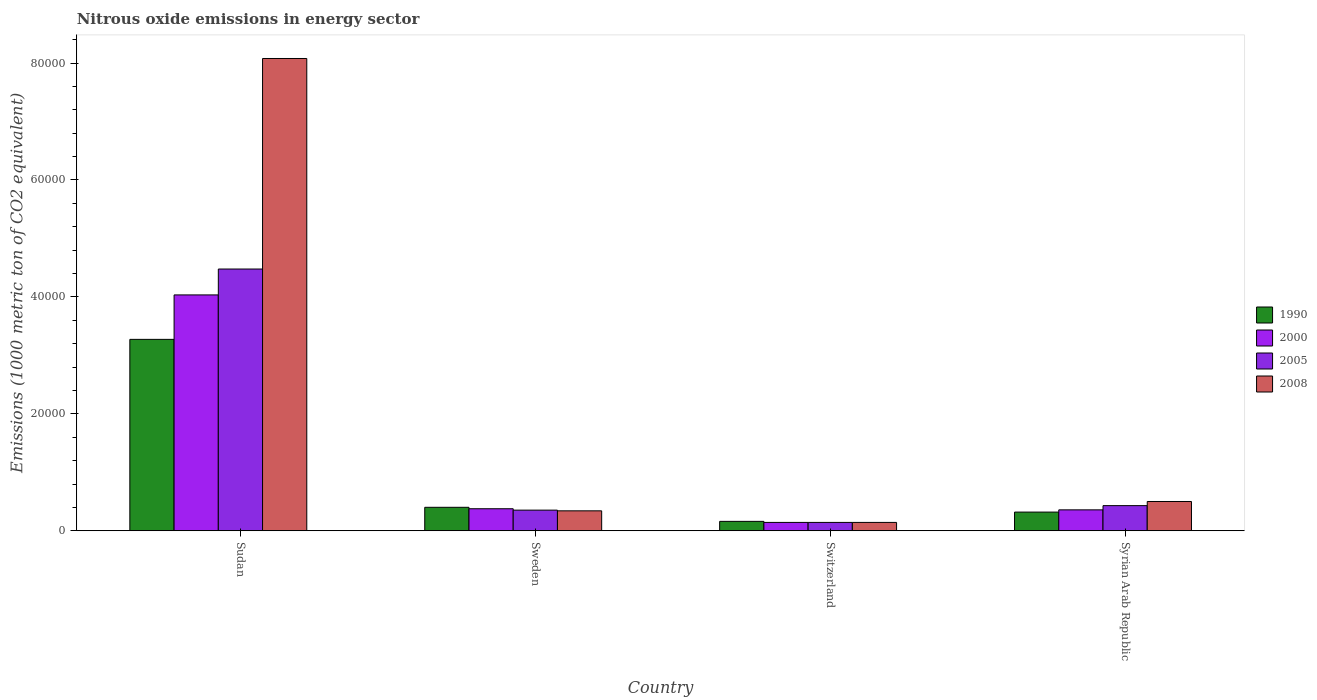How many different coloured bars are there?
Provide a succinct answer. 4. How many groups of bars are there?
Keep it short and to the point. 4. Are the number of bars per tick equal to the number of legend labels?
Provide a short and direct response. Yes. Are the number of bars on each tick of the X-axis equal?
Your answer should be compact. Yes. How many bars are there on the 2nd tick from the right?
Ensure brevity in your answer.  4. What is the label of the 1st group of bars from the left?
Ensure brevity in your answer.  Sudan. In how many cases, is the number of bars for a given country not equal to the number of legend labels?
Your response must be concise. 0. What is the amount of nitrous oxide emitted in 2005 in Syrian Arab Republic?
Make the answer very short. 4302.7. Across all countries, what is the maximum amount of nitrous oxide emitted in 2005?
Offer a very short reply. 4.48e+04. Across all countries, what is the minimum amount of nitrous oxide emitted in 1990?
Ensure brevity in your answer.  1610.2. In which country was the amount of nitrous oxide emitted in 2008 maximum?
Ensure brevity in your answer.  Sudan. In which country was the amount of nitrous oxide emitted in 2005 minimum?
Ensure brevity in your answer.  Switzerland. What is the total amount of nitrous oxide emitted in 2008 in the graph?
Offer a terse response. 9.06e+04. What is the difference between the amount of nitrous oxide emitted in 2005 in Sweden and that in Syrian Arab Republic?
Your answer should be compact. -769.3. What is the difference between the amount of nitrous oxide emitted in 2005 in Sudan and the amount of nitrous oxide emitted in 2008 in Sweden?
Your answer should be compact. 4.14e+04. What is the average amount of nitrous oxide emitted in 2008 per country?
Ensure brevity in your answer.  2.27e+04. What is the difference between the amount of nitrous oxide emitted of/in 2000 and amount of nitrous oxide emitted of/in 2008 in Sudan?
Provide a short and direct response. -4.04e+04. What is the ratio of the amount of nitrous oxide emitted in 1990 in Sudan to that in Sweden?
Make the answer very short. 8.15. Is the amount of nitrous oxide emitted in 1990 in Sudan less than that in Syrian Arab Republic?
Keep it short and to the point. No. What is the difference between the highest and the second highest amount of nitrous oxide emitted in 2005?
Your answer should be compact. -769.3. What is the difference between the highest and the lowest amount of nitrous oxide emitted in 2008?
Your answer should be compact. 7.93e+04. What does the 2nd bar from the left in Syrian Arab Republic represents?
Your response must be concise. 2000. Is it the case that in every country, the sum of the amount of nitrous oxide emitted in 1990 and amount of nitrous oxide emitted in 2000 is greater than the amount of nitrous oxide emitted in 2008?
Offer a very short reply. No. Are all the bars in the graph horizontal?
Your response must be concise. No. What is the difference between two consecutive major ticks on the Y-axis?
Offer a very short reply. 2.00e+04. Does the graph contain grids?
Keep it short and to the point. No. What is the title of the graph?
Provide a succinct answer. Nitrous oxide emissions in energy sector. What is the label or title of the Y-axis?
Ensure brevity in your answer.  Emissions (1000 metric ton of CO2 equivalent). What is the Emissions (1000 metric ton of CO2 equivalent) in 1990 in Sudan?
Provide a short and direct response. 3.27e+04. What is the Emissions (1000 metric ton of CO2 equivalent) in 2000 in Sudan?
Offer a very short reply. 4.03e+04. What is the Emissions (1000 metric ton of CO2 equivalent) of 2005 in Sudan?
Provide a succinct answer. 4.48e+04. What is the Emissions (1000 metric ton of CO2 equivalent) in 2008 in Sudan?
Offer a very short reply. 8.08e+04. What is the Emissions (1000 metric ton of CO2 equivalent) of 1990 in Sweden?
Ensure brevity in your answer.  4016.7. What is the Emissions (1000 metric ton of CO2 equivalent) in 2000 in Sweden?
Make the answer very short. 3769. What is the Emissions (1000 metric ton of CO2 equivalent) in 2005 in Sweden?
Offer a terse response. 3533.4. What is the Emissions (1000 metric ton of CO2 equivalent) in 2008 in Sweden?
Ensure brevity in your answer.  3412.4. What is the Emissions (1000 metric ton of CO2 equivalent) in 1990 in Switzerland?
Your answer should be compact. 1610.2. What is the Emissions (1000 metric ton of CO2 equivalent) in 2000 in Switzerland?
Your response must be concise. 1432.5. What is the Emissions (1000 metric ton of CO2 equivalent) in 2005 in Switzerland?
Offer a terse response. 1431.1. What is the Emissions (1000 metric ton of CO2 equivalent) in 2008 in Switzerland?
Make the answer very short. 1433. What is the Emissions (1000 metric ton of CO2 equivalent) of 1990 in Syrian Arab Republic?
Make the answer very short. 3198.5. What is the Emissions (1000 metric ton of CO2 equivalent) in 2000 in Syrian Arab Republic?
Ensure brevity in your answer.  3579.1. What is the Emissions (1000 metric ton of CO2 equivalent) in 2005 in Syrian Arab Republic?
Offer a very short reply. 4302.7. What is the Emissions (1000 metric ton of CO2 equivalent) of 2008 in Syrian Arab Republic?
Ensure brevity in your answer.  5009.9. Across all countries, what is the maximum Emissions (1000 metric ton of CO2 equivalent) in 1990?
Provide a succinct answer. 3.27e+04. Across all countries, what is the maximum Emissions (1000 metric ton of CO2 equivalent) in 2000?
Your response must be concise. 4.03e+04. Across all countries, what is the maximum Emissions (1000 metric ton of CO2 equivalent) in 2005?
Provide a succinct answer. 4.48e+04. Across all countries, what is the maximum Emissions (1000 metric ton of CO2 equivalent) of 2008?
Provide a short and direct response. 8.08e+04. Across all countries, what is the minimum Emissions (1000 metric ton of CO2 equivalent) in 1990?
Provide a succinct answer. 1610.2. Across all countries, what is the minimum Emissions (1000 metric ton of CO2 equivalent) in 2000?
Give a very brief answer. 1432.5. Across all countries, what is the minimum Emissions (1000 metric ton of CO2 equivalent) of 2005?
Make the answer very short. 1431.1. Across all countries, what is the minimum Emissions (1000 metric ton of CO2 equivalent) of 2008?
Provide a short and direct response. 1433. What is the total Emissions (1000 metric ton of CO2 equivalent) in 1990 in the graph?
Offer a terse response. 4.16e+04. What is the total Emissions (1000 metric ton of CO2 equivalent) in 2000 in the graph?
Your answer should be compact. 4.91e+04. What is the total Emissions (1000 metric ton of CO2 equivalent) of 2005 in the graph?
Keep it short and to the point. 5.40e+04. What is the total Emissions (1000 metric ton of CO2 equivalent) in 2008 in the graph?
Offer a terse response. 9.06e+04. What is the difference between the Emissions (1000 metric ton of CO2 equivalent) of 1990 in Sudan and that in Sweden?
Give a very brief answer. 2.87e+04. What is the difference between the Emissions (1000 metric ton of CO2 equivalent) in 2000 in Sudan and that in Sweden?
Provide a succinct answer. 3.66e+04. What is the difference between the Emissions (1000 metric ton of CO2 equivalent) in 2005 in Sudan and that in Sweden?
Provide a succinct answer. 4.12e+04. What is the difference between the Emissions (1000 metric ton of CO2 equivalent) in 2008 in Sudan and that in Sweden?
Your answer should be compact. 7.74e+04. What is the difference between the Emissions (1000 metric ton of CO2 equivalent) of 1990 in Sudan and that in Switzerland?
Make the answer very short. 3.11e+04. What is the difference between the Emissions (1000 metric ton of CO2 equivalent) in 2000 in Sudan and that in Switzerland?
Your answer should be compact. 3.89e+04. What is the difference between the Emissions (1000 metric ton of CO2 equivalent) of 2005 in Sudan and that in Switzerland?
Offer a very short reply. 4.33e+04. What is the difference between the Emissions (1000 metric ton of CO2 equivalent) in 2008 in Sudan and that in Switzerland?
Your answer should be compact. 7.93e+04. What is the difference between the Emissions (1000 metric ton of CO2 equivalent) of 1990 in Sudan and that in Syrian Arab Republic?
Give a very brief answer. 2.95e+04. What is the difference between the Emissions (1000 metric ton of CO2 equivalent) in 2000 in Sudan and that in Syrian Arab Republic?
Your answer should be very brief. 3.68e+04. What is the difference between the Emissions (1000 metric ton of CO2 equivalent) of 2005 in Sudan and that in Syrian Arab Republic?
Keep it short and to the point. 4.05e+04. What is the difference between the Emissions (1000 metric ton of CO2 equivalent) in 2008 in Sudan and that in Syrian Arab Republic?
Offer a terse response. 7.58e+04. What is the difference between the Emissions (1000 metric ton of CO2 equivalent) in 1990 in Sweden and that in Switzerland?
Keep it short and to the point. 2406.5. What is the difference between the Emissions (1000 metric ton of CO2 equivalent) of 2000 in Sweden and that in Switzerland?
Your answer should be very brief. 2336.5. What is the difference between the Emissions (1000 metric ton of CO2 equivalent) in 2005 in Sweden and that in Switzerland?
Your answer should be compact. 2102.3. What is the difference between the Emissions (1000 metric ton of CO2 equivalent) in 2008 in Sweden and that in Switzerland?
Offer a terse response. 1979.4. What is the difference between the Emissions (1000 metric ton of CO2 equivalent) in 1990 in Sweden and that in Syrian Arab Republic?
Provide a succinct answer. 818.2. What is the difference between the Emissions (1000 metric ton of CO2 equivalent) of 2000 in Sweden and that in Syrian Arab Republic?
Make the answer very short. 189.9. What is the difference between the Emissions (1000 metric ton of CO2 equivalent) in 2005 in Sweden and that in Syrian Arab Republic?
Offer a terse response. -769.3. What is the difference between the Emissions (1000 metric ton of CO2 equivalent) of 2008 in Sweden and that in Syrian Arab Republic?
Keep it short and to the point. -1597.5. What is the difference between the Emissions (1000 metric ton of CO2 equivalent) in 1990 in Switzerland and that in Syrian Arab Republic?
Provide a short and direct response. -1588.3. What is the difference between the Emissions (1000 metric ton of CO2 equivalent) in 2000 in Switzerland and that in Syrian Arab Republic?
Keep it short and to the point. -2146.6. What is the difference between the Emissions (1000 metric ton of CO2 equivalent) of 2005 in Switzerland and that in Syrian Arab Republic?
Your answer should be compact. -2871.6. What is the difference between the Emissions (1000 metric ton of CO2 equivalent) in 2008 in Switzerland and that in Syrian Arab Republic?
Provide a short and direct response. -3576.9. What is the difference between the Emissions (1000 metric ton of CO2 equivalent) of 1990 in Sudan and the Emissions (1000 metric ton of CO2 equivalent) of 2000 in Sweden?
Provide a short and direct response. 2.90e+04. What is the difference between the Emissions (1000 metric ton of CO2 equivalent) of 1990 in Sudan and the Emissions (1000 metric ton of CO2 equivalent) of 2005 in Sweden?
Provide a succinct answer. 2.92e+04. What is the difference between the Emissions (1000 metric ton of CO2 equivalent) of 1990 in Sudan and the Emissions (1000 metric ton of CO2 equivalent) of 2008 in Sweden?
Offer a terse response. 2.93e+04. What is the difference between the Emissions (1000 metric ton of CO2 equivalent) in 2000 in Sudan and the Emissions (1000 metric ton of CO2 equivalent) in 2005 in Sweden?
Give a very brief answer. 3.68e+04. What is the difference between the Emissions (1000 metric ton of CO2 equivalent) of 2000 in Sudan and the Emissions (1000 metric ton of CO2 equivalent) of 2008 in Sweden?
Keep it short and to the point. 3.69e+04. What is the difference between the Emissions (1000 metric ton of CO2 equivalent) of 2005 in Sudan and the Emissions (1000 metric ton of CO2 equivalent) of 2008 in Sweden?
Keep it short and to the point. 4.14e+04. What is the difference between the Emissions (1000 metric ton of CO2 equivalent) in 1990 in Sudan and the Emissions (1000 metric ton of CO2 equivalent) in 2000 in Switzerland?
Your answer should be compact. 3.13e+04. What is the difference between the Emissions (1000 metric ton of CO2 equivalent) of 1990 in Sudan and the Emissions (1000 metric ton of CO2 equivalent) of 2005 in Switzerland?
Your response must be concise. 3.13e+04. What is the difference between the Emissions (1000 metric ton of CO2 equivalent) of 1990 in Sudan and the Emissions (1000 metric ton of CO2 equivalent) of 2008 in Switzerland?
Your answer should be compact. 3.13e+04. What is the difference between the Emissions (1000 metric ton of CO2 equivalent) of 2000 in Sudan and the Emissions (1000 metric ton of CO2 equivalent) of 2005 in Switzerland?
Your answer should be very brief. 3.89e+04. What is the difference between the Emissions (1000 metric ton of CO2 equivalent) in 2000 in Sudan and the Emissions (1000 metric ton of CO2 equivalent) in 2008 in Switzerland?
Keep it short and to the point. 3.89e+04. What is the difference between the Emissions (1000 metric ton of CO2 equivalent) in 2005 in Sudan and the Emissions (1000 metric ton of CO2 equivalent) in 2008 in Switzerland?
Provide a short and direct response. 4.33e+04. What is the difference between the Emissions (1000 metric ton of CO2 equivalent) of 1990 in Sudan and the Emissions (1000 metric ton of CO2 equivalent) of 2000 in Syrian Arab Republic?
Your response must be concise. 2.92e+04. What is the difference between the Emissions (1000 metric ton of CO2 equivalent) of 1990 in Sudan and the Emissions (1000 metric ton of CO2 equivalent) of 2005 in Syrian Arab Republic?
Give a very brief answer. 2.84e+04. What is the difference between the Emissions (1000 metric ton of CO2 equivalent) in 1990 in Sudan and the Emissions (1000 metric ton of CO2 equivalent) in 2008 in Syrian Arab Republic?
Give a very brief answer. 2.77e+04. What is the difference between the Emissions (1000 metric ton of CO2 equivalent) in 2000 in Sudan and the Emissions (1000 metric ton of CO2 equivalent) in 2005 in Syrian Arab Republic?
Provide a short and direct response. 3.60e+04. What is the difference between the Emissions (1000 metric ton of CO2 equivalent) in 2000 in Sudan and the Emissions (1000 metric ton of CO2 equivalent) in 2008 in Syrian Arab Republic?
Your answer should be very brief. 3.53e+04. What is the difference between the Emissions (1000 metric ton of CO2 equivalent) in 2005 in Sudan and the Emissions (1000 metric ton of CO2 equivalent) in 2008 in Syrian Arab Republic?
Give a very brief answer. 3.98e+04. What is the difference between the Emissions (1000 metric ton of CO2 equivalent) of 1990 in Sweden and the Emissions (1000 metric ton of CO2 equivalent) of 2000 in Switzerland?
Give a very brief answer. 2584.2. What is the difference between the Emissions (1000 metric ton of CO2 equivalent) in 1990 in Sweden and the Emissions (1000 metric ton of CO2 equivalent) in 2005 in Switzerland?
Your answer should be very brief. 2585.6. What is the difference between the Emissions (1000 metric ton of CO2 equivalent) in 1990 in Sweden and the Emissions (1000 metric ton of CO2 equivalent) in 2008 in Switzerland?
Offer a very short reply. 2583.7. What is the difference between the Emissions (1000 metric ton of CO2 equivalent) in 2000 in Sweden and the Emissions (1000 metric ton of CO2 equivalent) in 2005 in Switzerland?
Provide a short and direct response. 2337.9. What is the difference between the Emissions (1000 metric ton of CO2 equivalent) in 2000 in Sweden and the Emissions (1000 metric ton of CO2 equivalent) in 2008 in Switzerland?
Offer a very short reply. 2336. What is the difference between the Emissions (1000 metric ton of CO2 equivalent) in 2005 in Sweden and the Emissions (1000 metric ton of CO2 equivalent) in 2008 in Switzerland?
Your answer should be very brief. 2100.4. What is the difference between the Emissions (1000 metric ton of CO2 equivalent) of 1990 in Sweden and the Emissions (1000 metric ton of CO2 equivalent) of 2000 in Syrian Arab Republic?
Provide a short and direct response. 437.6. What is the difference between the Emissions (1000 metric ton of CO2 equivalent) in 1990 in Sweden and the Emissions (1000 metric ton of CO2 equivalent) in 2005 in Syrian Arab Republic?
Provide a succinct answer. -286. What is the difference between the Emissions (1000 metric ton of CO2 equivalent) in 1990 in Sweden and the Emissions (1000 metric ton of CO2 equivalent) in 2008 in Syrian Arab Republic?
Provide a succinct answer. -993.2. What is the difference between the Emissions (1000 metric ton of CO2 equivalent) of 2000 in Sweden and the Emissions (1000 metric ton of CO2 equivalent) of 2005 in Syrian Arab Republic?
Provide a short and direct response. -533.7. What is the difference between the Emissions (1000 metric ton of CO2 equivalent) of 2000 in Sweden and the Emissions (1000 metric ton of CO2 equivalent) of 2008 in Syrian Arab Republic?
Ensure brevity in your answer.  -1240.9. What is the difference between the Emissions (1000 metric ton of CO2 equivalent) in 2005 in Sweden and the Emissions (1000 metric ton of CO2 equivalent) in 2008 in Syrian Arab Republic?
Make the answer very short. -1476.5. What is the difference between the Emissions (1000 metric ton of CO2 equivalent) in 1990 in Switzerland and the Emissions (1000 metric ton of CO2 equivalent) in 2000 in Syrian Arab Republic?
Offer a terse response. -1968.9. What is the difference between the Emissions (1000 metric ton of CO2 equivalent) in 1990 in Switzerland and the Emissions (1000 metric ton of CO2 equivalent) in 2005 in Syrian Arab Republic?
Give a very brief answer. -2692.5. What is the difference between the Emissions (1000 metric ton of CO2 equivalent) of 1990 in Switzerland and the Emissions (1000 metric ton of CO2 equivalent) of 2008 in Syrian Arab Republic?
Provide a succinct answer. -3399.7. What is the difference between the Emissions (1000 metric ton of CO2 equivalent) of 2000 in Switzerland and the Emissions (1000 metric ton of CO2 equivalent) of 2005 in Syrian Arab Republic?
Offer a very short reply. -2870.2. What is the difference between the Emissions (1000 metric ton of CO2 equivalent) of 2000 in Switzerland and the Emissions (1000 metric ton of CO2 equivalent) of 2008 in Syrian Arab Republic?
Provide a short and direct response. -3577.4. What is the difference between the Emissions (1000 metric ton of CO2 equivalent) in 2005 in Switzerland and the Emissions (1000 metric ton of CO2 equivalent) in 2008 in Syrian Arab Republic?
Offer a terse response. -3578.8. What is the average Emissions (1000 metric ton of CO2 equivalent) in 1990 per country?
Give a very brief answer. 1.04e+04. What is the average Emissions (1000 metric ton of CO2 equivalent) in 2000 per country?
Ensure brevity in your answer.  1.23e+04. What is the average Emissions (1000 metric ton of CO2 equivalent) in 2005 per country?
Your answer should be very brief. 1.35e+04. What is the average Emissions (1000 metric ton of CO2 equivalent) in 2008 per country?
Give a very brief answer. 2.27e+04. What is the difference between the Emissions (1000 metric ton of CO2 equivalent) of 1990 and Emissions (1000 metric ton of CO2 equivalent) of 2000 in Sudan?
Make the answer very short. -7600.6. What is the difference between the Emissions (1000 metric ton of CO2 equivalent) of 1990 and Emissions (1000 metric ton of CO2 equivalent) of 2005 in Sudan?
Provide a short and direct response. -1.20e+04. What is the difference between the Emissions (1000 metric ton of CO2 equivalent) of 1990 and Emissions (1000 metric ton of CO2 equivalent) of 2008 in Sudan?
Keep it short and to the point. -4.80e+04. What is the difference between the Emissions (1000 metric ton of CO2 equivalent) in 2000 and Emissions (1000 metric ton of CO2 equivalent) in 2005 in Sudan?
Ensure brevity in your answer.  -4429.1. What is the difference between the Emissions (1000 metric ton of CO2 equivalent) in 2000 and Emissions (1000 metric ton of CO2 equivalent) in 2008 in Sudan?
Offer a very short reply. -4.04e+04. What is the difference between the Emissions (1000 metric ton of CO2 equivalent) of 2005 and Emissions (1000 metric ton of CO2 equivalent) of 2008 in Sudan?
Ensure brevity in your answer.  -3.60e+04. What is the difference between the Emissions (1000 metric ton of CO2 equivalent) of 1990 and Emissions (1000 metric ton of CO2 equivalent) of 2000 in Sweden?
Ensure brevity in your answer.  247.7. What is the difference between the Emissions (1000 metric ton of CO2 equivalent) in 1990 and Emissions (1000 metric ton of CO2 equivalent) in 2005 in Sweden?
Give a very brief answer. 483.3. What is the difference between the Emissions (1000 metric ton of CO2 equivalent) in 1990 and Emissions (1000 metric ton of CO2 equivalent) in 2008 in Sweden?
Offer a very short reply. 604.3. What is the difference between the Emissions (1000 metric ton of CO2 equivalent) in 2000 and Emissions (1000 metric ton of CO2 equivalent) in 2005 in Sweden?
Your response must be concise. 235.6. What is the difference between the Emissions (1000 metric ton of CO2 equivalent) of 2000 and Emissions (1000 metric ton of CO2 equivalent) of 2008 in Sweden?
Provide a succinct answer. 356.6. What is the difference between the Emissions (1000 metric ton of CO2 equivalent) of 2005 and Emissions (1000 metric ton of CO2 equivalent) of 2008 in Sweden?
Your answer should be very brief. 121. What is the difference between the Emissions (1000 metric ton of CO2 equivalent) of 1990 and Emissions (1000 metric ton of CO2 equivalent) of 2000 in Switzerland?
Ensure brevity in your answer.  177.7. What is the difference between the Emissions (1000 metric ton of CO2 equivalent) in 1990 and Emissions (1000 metric ton of CO2 equivalent) in 2005 in Switzerland?
Provide a succinct answer. 179.1. What is the difference between the Emissions (1000 metric ton of CO2 equivalent) in 1990 and Emissions (1000 metric ton of CO2 equivalent) in 2008 in Switzerland?
Provide a succinct answer. 177.2. What is the difference between the Emissions (1000 metric ton of CO2 equivalent) of 2000 and Emissions (1000 metric ton of CO2 equivalent) of 2008 in Switzerland?
Keep it short and to the point. -0.5. What is the difference between the Emissions (1000 metric ton of CO2 equivalent) of 2005 and Emissions (1000 metric ton of CO2 equivalent) of 2008 in Switzerland?
Offer a terse response. -1.9. What is the difference between the Emissions (1000 metric ton of CO2 equivalent) in 1990 and Emissions (1000 metric ton of CO2 equivalent) in 2000 in Syrian Arab Republic?
Make the answer very short. -380.6. What is the difference between the Emissions (1000 metric ton of CO2 equivalent) of 1990 and Emissions (1000 metric ton of CO2 equivalent) of 2005 in Syrian Arab Republic?
Keep it short and to the point. -1104.2. What is the difference between the Emissions (1000 metric ton of CO2 equivalent) in 1990 and Emissions (1000 metric ton of CO2 equivalent) in 2008 in Syrian Arab Republic?
Provide a succinct answer. -1811.4. What is the difference between the Emissions (1000 metric ton of CO2 equivalent) of 2000 and Emissions (1000 metric ton of CO2 equivalent) of 2005 in Syrian Arab Republic?
Provide a short and direct response. -723.6. What is the difference between the Emissions (1000 metric ton of CO2 equivalent) of 2000 and Emissions (1000 metric ton of CO2 equivalent) of 2008 in Syrian Arab Republic?
Provide a short and direct response. -1430.8. What is the difference between the Emissions (1000 metric ton of CO2 equivalent) in 2005 and Emissions (1000 metric ton of CO2 equivalent) in 2008 in Syrian Arab Republic?
Provide a short and direct response. -707.2. What is the ratio of the Emissions (1000 metric ton of CO2 equivalent) in 1990 in Sudan to that in Sweden?
Your answer should be very brief. 8.15. What is the ratio of the Emissions (1000 metric ton of CO2 equivalent) in 2000 in Sudan to that in Sweden?
Give a very brief answer. 10.7. What is the ratio of the Emissions (1000 metric ton of CO2 equivalent) in 2005 in Sudan to that in Sweden?
Your answer should be very brief. 12.67. What is the ratio of the Emissions (1000 metric ton of CO2 equivalent) in 2008 in Sudan to that in Sweden?
Your response must be concise. 23.67. What is the ratio of the Emissions (1000 metric ton of CO2 equivalent) in 1990 in Sudan to that in Switzerland?
Your answer should be very brief. 20.33. What is the ratio of the Emissions (1000 metric ton of CO2 equivalent) in 2000 in Sudan to that in Switzerland?
Make the answer very short. 28.16. What is the ratio of the Emissions (1000 metric ton of CO2 equivalent) of 2005 in Sudan to that in Switzerland?
Make the answer very short. 31.28. What is the ratio of the Emissions (1000 metric ton of CO2 equivalent) of 2008 in Sudan to that in Switzerland?
Provide a succinct answer. 56.37. What is the ratio of the Emissions (1000 metric ton of CO2 equivalent) in 1990 in Sudan to that in Syrian Arab Republic?
Offer a terse response. 10.24. What is the ratio of the Emissions (1000 metric ton of CO2 equivalent) in 2000 in Sudan to that in Syrian Arab Republic?
Your answer should be very brief. 11.27. What is the ratio of the Emissions (1000 metric ton of CO2 equivalent) of 2005 in Sudan to that in Syrian Arab Republic?
Ensure brevity in your answer.  10.4. What is the ratio of the Emissions (1000 metric ton of CO2 equivalent) of 2008 in Sudan to that in Syrian Arab Republic?
Make the answer very short. 16.12. What is the ratio of the Emissions (1000 metric ton of CO2 equivalent) of 1990 in Sweden to that in Switzerland?
Keep it short and to the point. 2.49. What is the ratio of the Emissions (1000 metric ton of CO2 equivalent) in 2000 in Sweden to that in Switzerland?
Offer a terse response. 2.63. What is the ratio of the Emissions (1000 metric ton of CO2 equivalent) of 2005 in Sweden to that in Switzerland?
Your answer should be very brief. 2.47. What is the ratio of the Emissions (1000 metric ton of CO2 equivalent) in 2008 in Sweden to that in Switzerland?
Your answer should be compact. 2.38. What is the ratio of the Emissions (1000 metric ton of CO2 equivalent) of 1990 in Sweden to that in Syrian Arab Republic?
Your answer should be compact. 1.26. What is the ratio of the Emissions (1000 metric ton of CO2 equivalent) in 2000 in Sweden to that in Syrian Arab Republic?
Provide a succinct answer. 1.05. What is the ratio of the Emissions (1000 metric ton of CO2 equivalent) of 2005 in Sweden to that in Syrian Arab Republic?
Ensure brevity in your answer.  0.82. What is the ratio of the Emissions (1000 metric ton of CO2 equivalent) in 2008 in Sweden to that in Syrian Arab Republic?
Provide a succinct answer. 0.68. What is the ratio of the Emissions (1000 metric ton of CO2 equivalent) in 1990 in Switzerland to that in Syrian Arab Republic?
Your response must be concise. 0.5. What is the ratio of the Emissions (1000 metric ton of CO2 equivalent) in 2000 in Switzerland to that in Syrian Arab Republic?
Ensure brevity in your answer.  0.4. What is the ratio of the Emissions (1000 metric ton of CO2 equivalent) in 2005 in Switzerland to that in Syrian Arab Republic?
Offer a very short reply. 0.33. What is the ratio of the Emissions (1000 metric ton of CO2 equivalent) of 2008 in Switzerland to that in Syrian Arab Republic?
Keep it short and to the point. 0.29. What is the difference between the highest and the second highest Emissions (1000 metric ton of CO2 equivalent) in 1990?
Make the answer very short. 2.87e+04. What is the difference between the highest and the second highest Emissions (1000 metric ton of CO2 equivalent) in 2000?
Give a very brief answer. 3.66e+04. What is the difference between the highest and the second highest Emissions (1000 metric ton of CO2 equivalent) in 2005?
Ensure brevity in your answer.  4.05e+04. What is the difference between the highest and the second highest Emissions (1000 metric ton of CO2 equivalent) in 2008?
Your response must be concise. 7.58e+04. What is the difference between the highest and the lowest Emissions (1000 metric ton of CO2 equivalent) in 1990?
Give a very brief answer. 3.11e+04. What is the difference between the highest and the lowest Emissions (1000 metric ton of CO2 equivalent) in 2000?
Offer a terse response. 3.89e+04. What is the difference between the highest and the lowest Emissions (1000 metric ton of CO2 equivalent) in 2005?
Provide a short and direct response. 4.33e+04. What is the difference between the highest and the lowest Emissions (1000 metric ton of CO2 equivalent) in 2008?
Make the answer very short. 7.93e+04. 